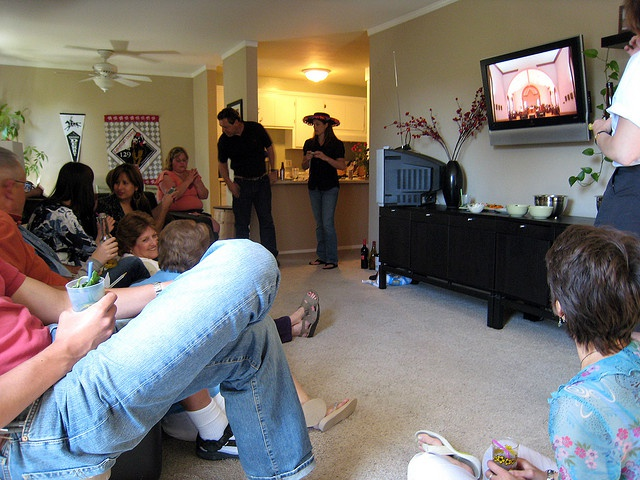Describe the objects in this image and their specific colors. I can see people in gray, white, and lightblue tones, people in gray, black, lightblue, and lavender tones, tv in gray, lightgray, black, and lightpink tones, people in gray, white, navy, black, and darkgray tones, and people in gray, black, maroon, and olive tones in this image. 